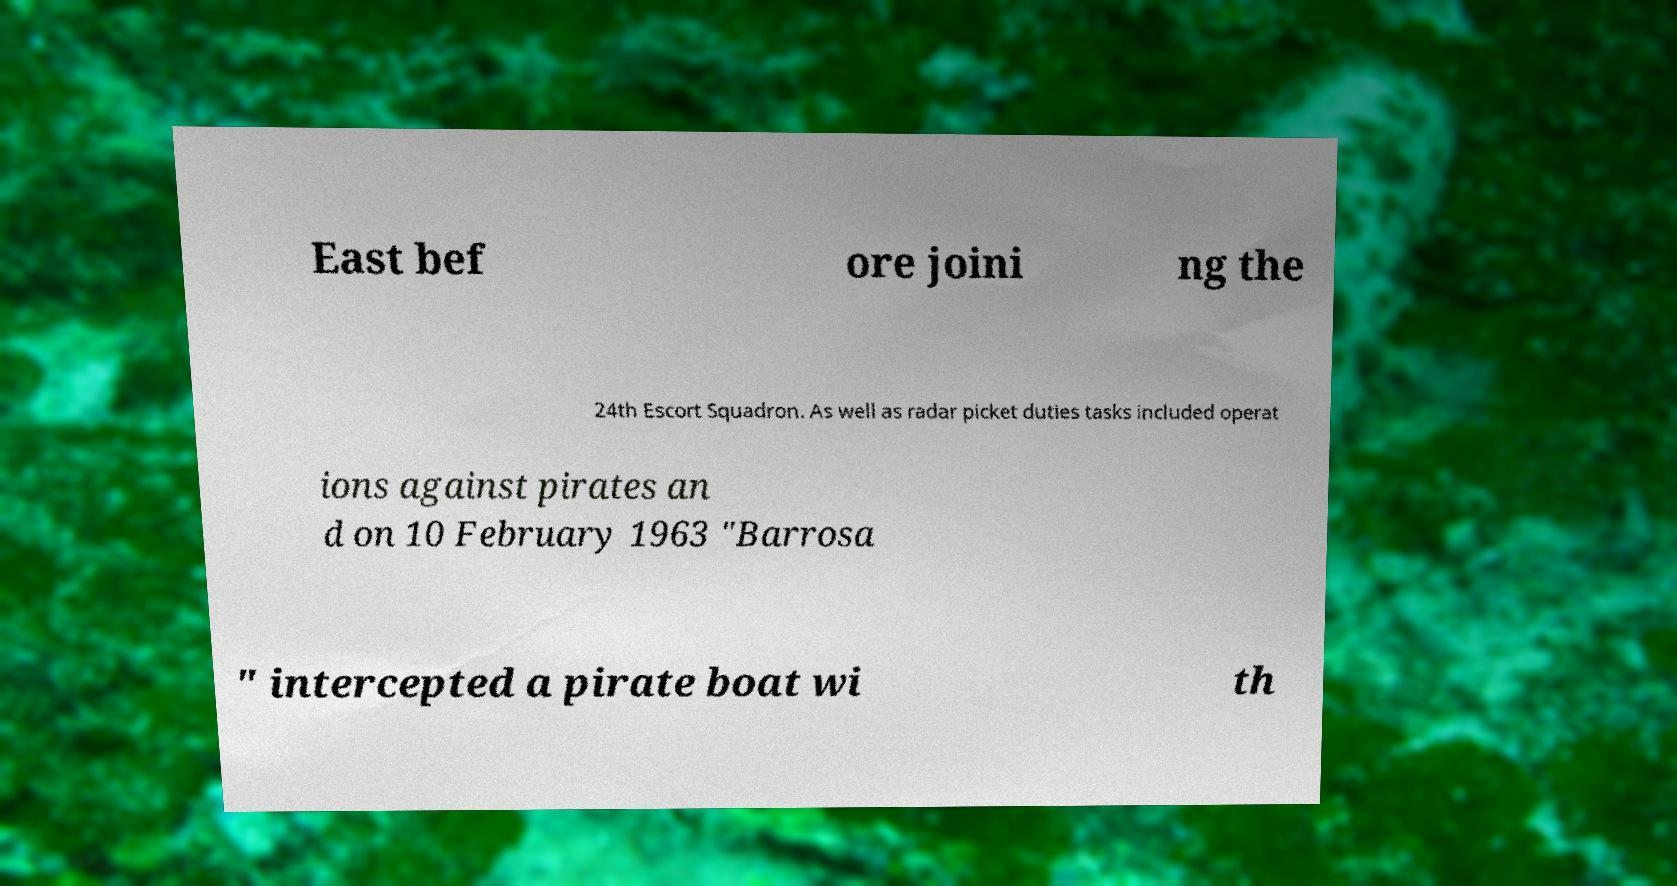Could you extract and type out the text from this image? East bef ore joini ng the 24th Escort Squadron. As well as radar picket duties tasks included operat ions against pirates an d on 10 February 1963 "Barrosa " intercepted a pirate boat wi th 